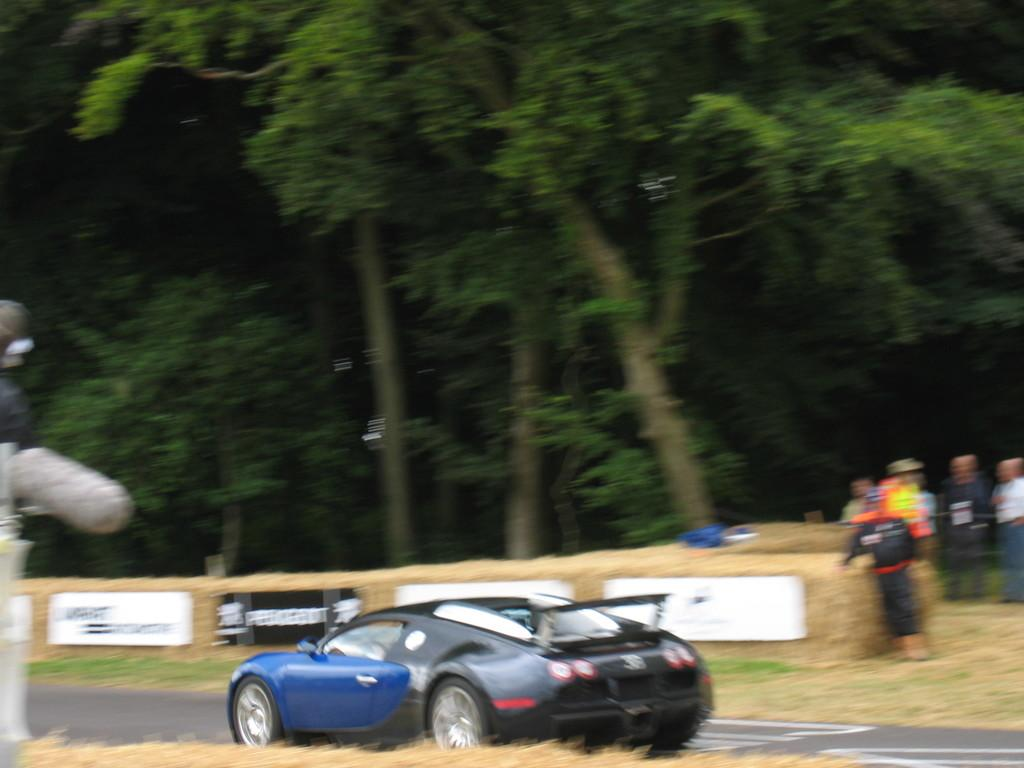What is on the road in the image? There is a vehicle on the road in the image. Who or what is present in the image besides the vehicle? There are people and trees in the image. What can be seen attached to a wall in the image? There are boards attached to a wall in the image. What else is on the wall besides the boards? There are objects on the wall in the image. Can you see a comb being used by someone in the image? There is no comb visible in the image. Is there an apple being eaten by someone in the image? There is no apple present in the image. 